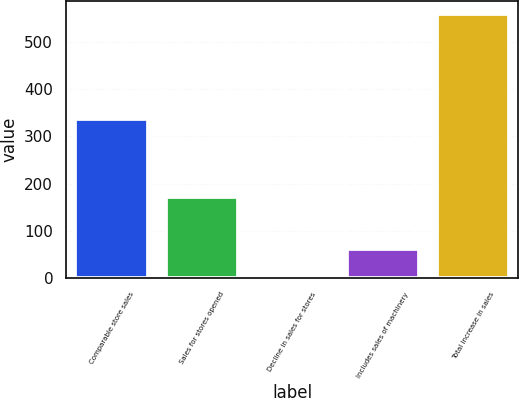Convert chart to OTSL. <chart><loc_0><loc_0><loc_500><loc_500><bar_chart><fcel>Comparable store sales<fcel>Sales for stores opened<fcel>Decline in sales for stores<fcel>Includes sales of machinery<fcel>Total increase in sales<nl><fcel>336<fcel>172.6<fcel>7<fcel>62.2<fcel>559<nl></chart> 